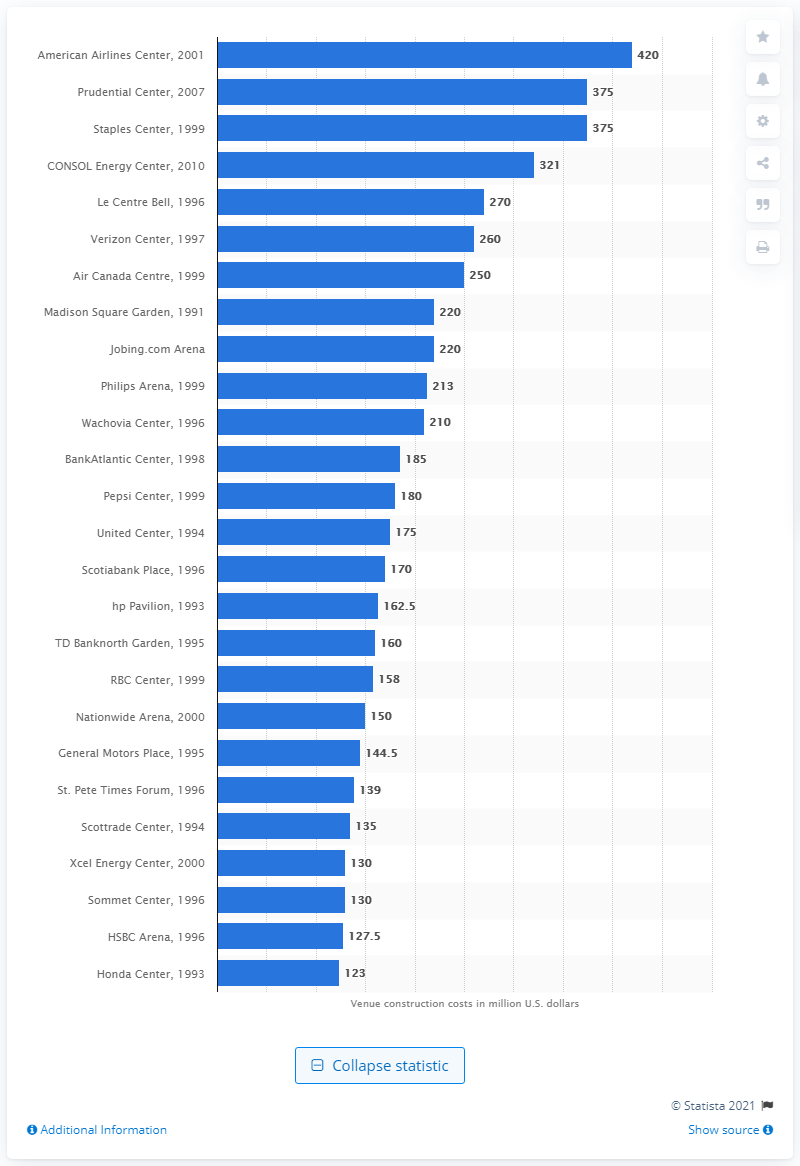Give some essential details in this illustration. The construction cost of the Scottrade Center was approximately $135 million. 